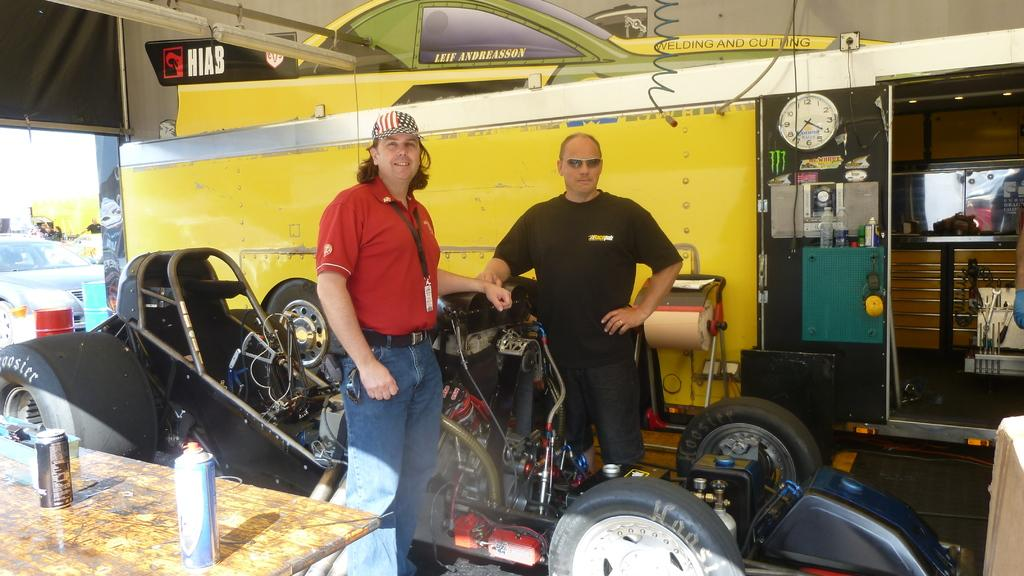How many men are present in the image? There are two men standing in the image. What is the facial expression of the men? The men are smiling. What types of vehicles can be seen in the image? There are vehicles in the image, but the specific types are not mentioned. What items are present for holding liquids? There are bottles in the image. What time-keeping device is visible in the image? There is a clock in the image. What type of furniture is present in the image? There are tables in the image. What type of wall decorations are present in the image? There are posters in the image. What large, cylindrical containers are present in the image? There are barrels in the image. Can you describe any unspecified objects in the image? There are some unspecified objects in the image, but their details are not mentioned. What type of island can be seen in the image? There is no island present in the image. What type of weather condition is depicted in the image? The provided facts do not mention any weather conditions, so it cannot be determined from the image. 